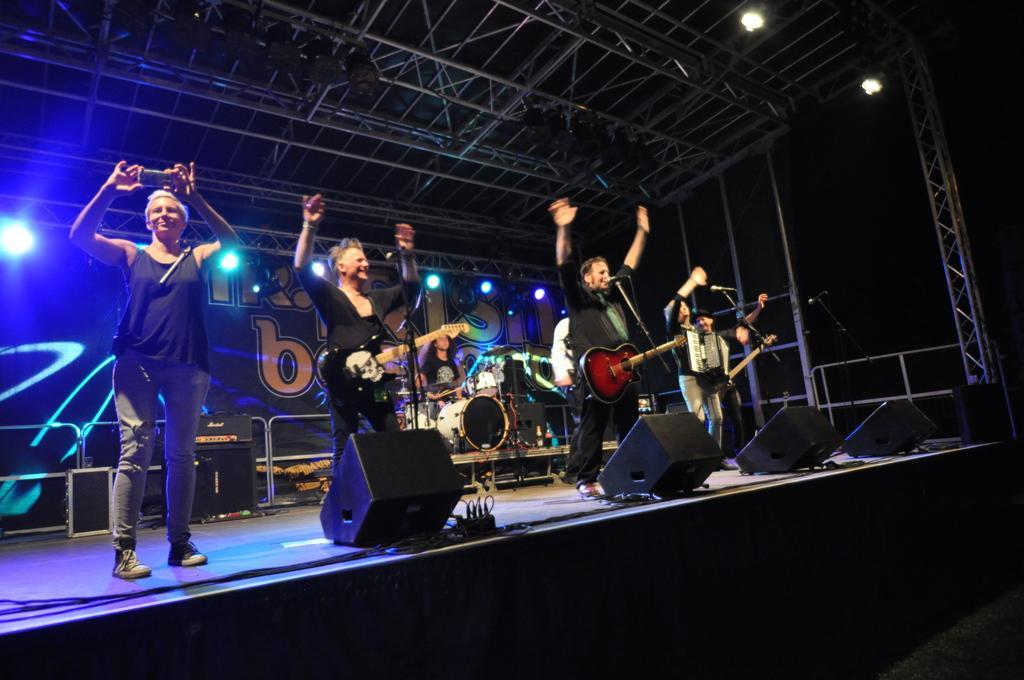Can you describe this image briefly? This image is clicked in a concert. There are six people on the dais. At the bottom, there are four speakers. To the left, the man wearing black t-shirt is holding a mobile. In the background, there is a banner along with stands. 